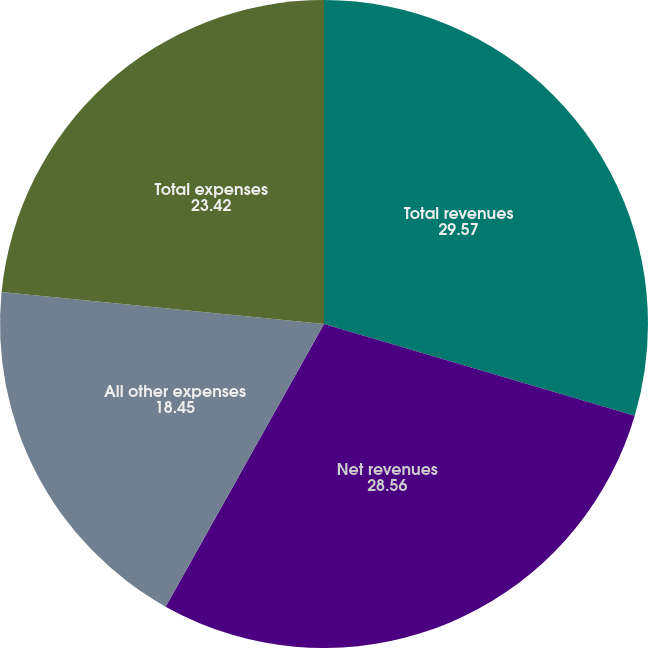Convert chart. <chart><loc_0><loc_0><loc_500><loc_500><pie_chart><fcel>Total revenues<fcel>Net revenues<fcel>All other expenses<fcel>Total expenses<nl><fcel>29.57%<fcel>28.56%<fcel>18.45%<fcel>23.42%<nl></chart> 